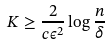<formula> <loc_0><loc_0><loc_500><loc_500>K \geq \frac { 2 } { c \epsilon ^ { 2 } } \log \frac { n } { \delta }</formula> 